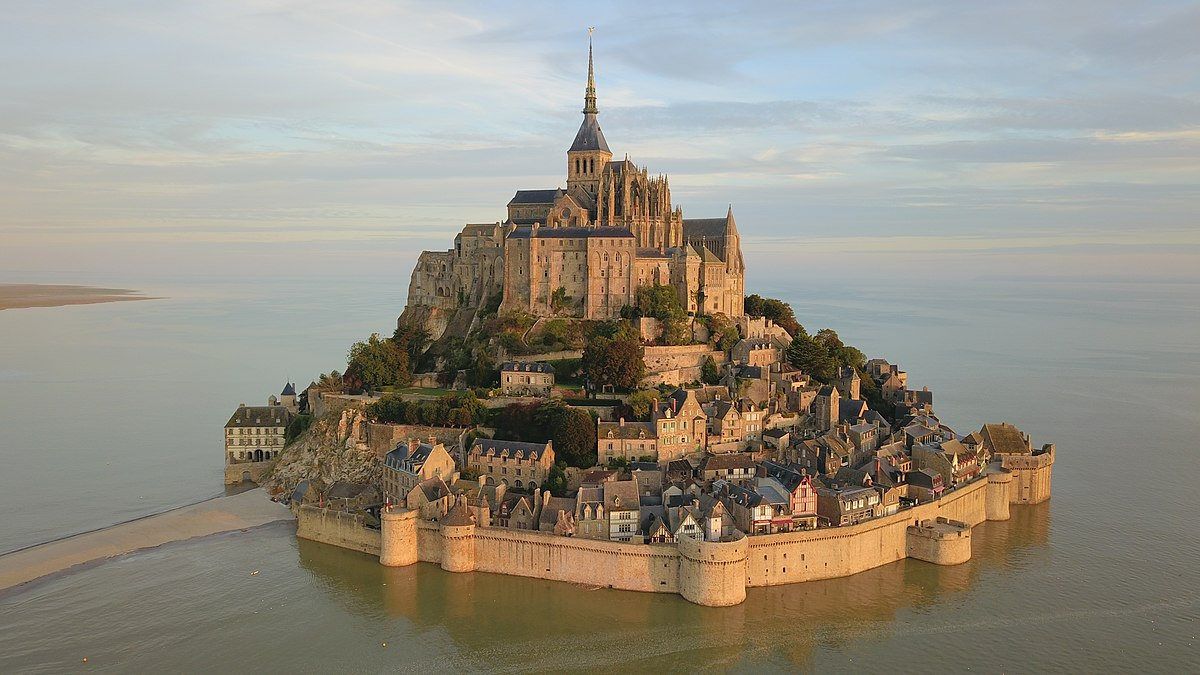This place looks ancient and magnificent. Can you tell me more about its history? Mont St Michel has a rich and storied history dating back to the 8th century when it was founded as a small settlement by the Bishop of Avranches, Aubert. According to legend, the archangel Michael appeared to Aubert in a dream, instructing him to build a church on the rocky island. Over the centuries, the site evolved, with construction of the Gothic abbey beginning in the 10th century and continuing into the 16th century. During the Middle Ages, Mont St Michel became a renowned center for learning, attracting scholars from all over Europe. The island also played a significant defensive role during the Hundred Years' War, withstanding sieges and attacks thanks to its natural fortifications. Over time, it became a major pilgrimage site and remains one of France's most cherished cultural and historical landmarks, drawing millions of visitors each year. What are some unique architectural features of Mont St Michel? Mont St Michel boasts several unique architectural features that make it a marvel of medieval design and engineering. One of the most striking features is the abbey's towering spire, crowned with a statue of the archangel Michael. The spire, along with the Gothic buttresses and pointed arches, exemplifies the height of medieval Gothic architecture. The Grand Degré, a steep and narrow staircase, leads pilgrims and visitors up to the abbey, emphasizing the island's verticality. The fortified walls and bastions surrounding the island are equipped with loopholes for arrows and cannon ports, reflecting its military significance. The layout of the village itself is a maze of narrow, cobbled streets that wind and twist, adding a quaint character to the rugged terrain. Additionally, the cloisters and the monks' refectory within the abbey highlight the simplicity and elegance of monastic life. These elements collectively showcase Mont St Michel as a harmonious blend of spiritual, military, and communal architecture. 